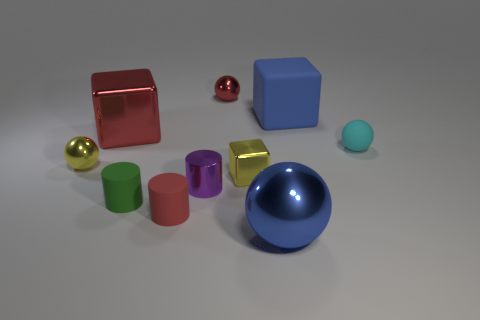Subtract all purple spheres. Subtract all red cubes. How many spheres are left? 4 Subtract all cylinders. How many objects are left? 7 Subtract 0 gray cubes. How many objects are left? 10 Subtract all red shiny objects. Subtract all tiny spheres. How many objects are left? 5 Add 5 large shiny balls. How many large shiny balls are left? 6 Add 9 yellow spheres. How many yellow spheres exist? 10 